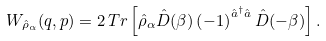<formula> <loc_0><loc_0><loc_500><loc_500>W _ { \hat { \rho } _ { \alpha } } ( q , p ) = 2 \, T r \left [ \hat { \rho } _ { \alpha } \hat { D } ( \beta ) \left ( - 1 \right ) ^ { \hat { a } ^ { \dagger } \hat { a } } \hat { D } ( - \beta ) \right ] .</formula> 